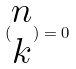Convert formula to latex. <formula><loc_0><loc_0><loc_500><loc_500>( \begin{matrix} n \\ k \end{matrix} ) = 0</formula> 